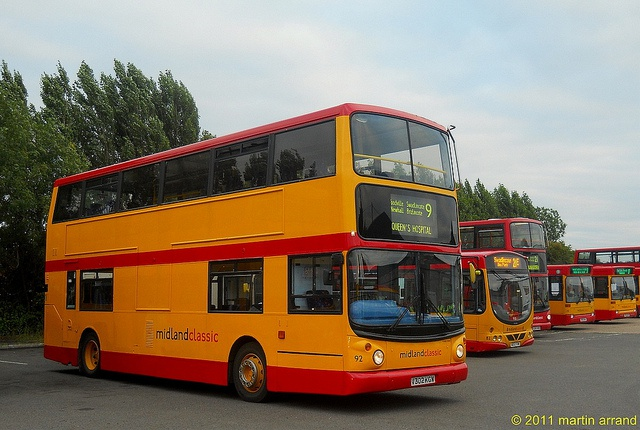Describe the objects in this image and their specific colors. I can see bus in lightgray, black, orange, red, and gray tones, bus in lightgray, black, red, gray, and maroon tones, bus in lightgray, black, gray, brown, and maroon tones, bus in lightgray, brown, black, gray, and maroon tones, and bus in lightgray, black, red, maroon, and gray tones in this image. 